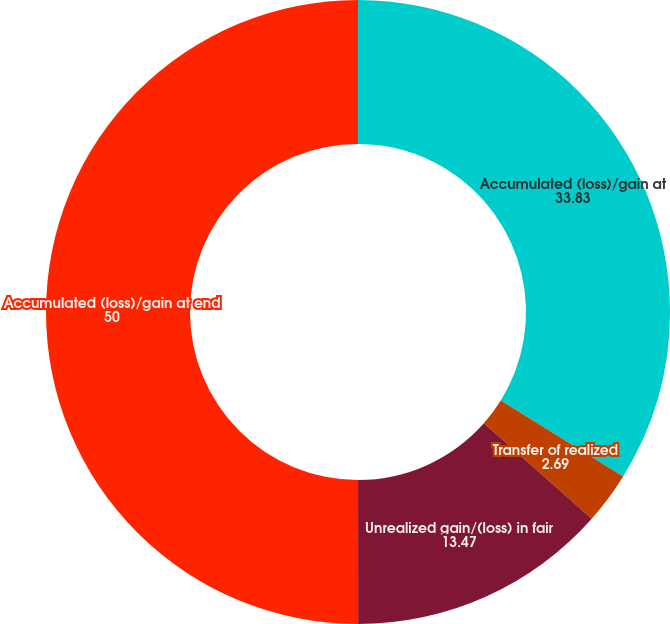Convert chart to OTSL. <chart><loc_0><loc_0><loc_500><loc_500><pie_chart><fcel>Accumulated (loss)/gain at<fcel>Transfer of realized<fcel>Unrealized gain/(loss) in fair<fcel>Accumulated (loss)/gain at end<nl><fcel>33.83%<fcel>2.69%<fcel>13.47%<fcel>50.0%<nl></chart> 